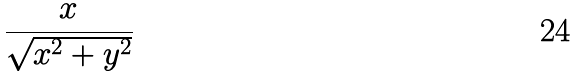<formula> <loc_0><loc_0><loc_500><loc_500>\frac { x } { \sqrt { x ^ { 2 } + y ^ { 2 } } }</formula> 